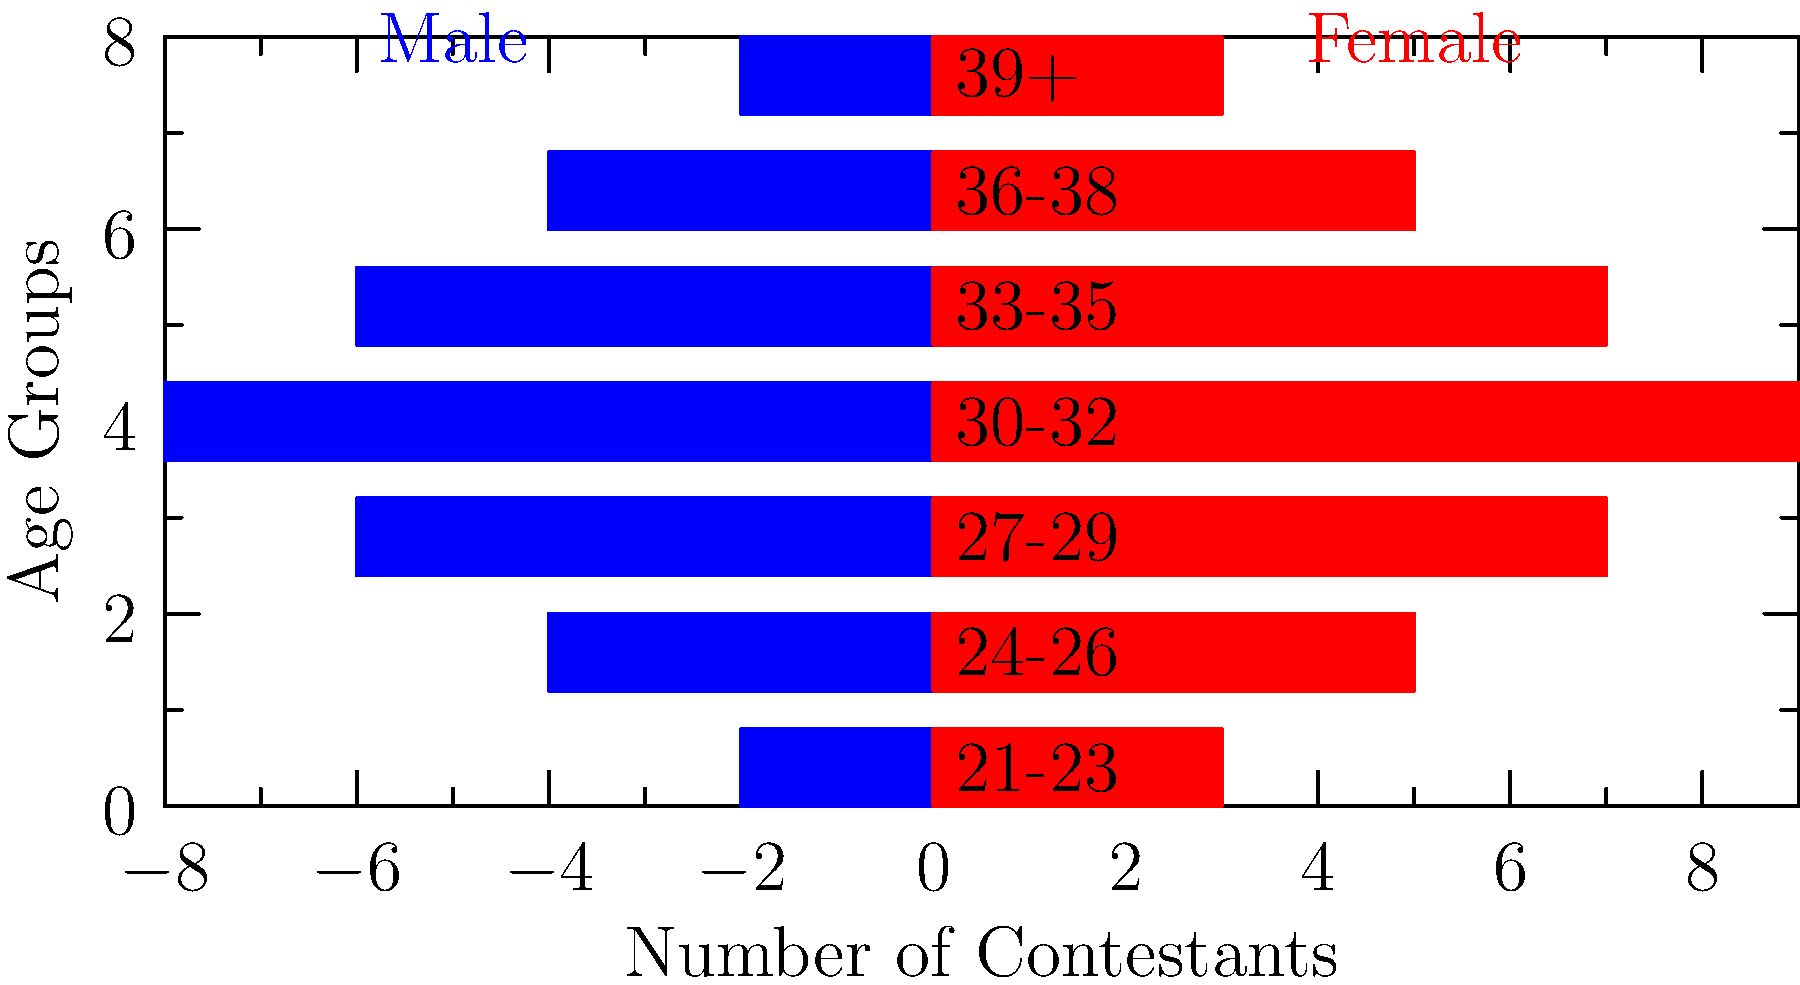Based on the population pyramid shown, which age group demonstrates the most significant gender disparity among contestants, and what might this imply about casting strategies for The Bachelor franchise? To answer this question, we need to analyze the population pyramid step-by-step:

1. Examine each age group:
   21-23: Male = 2, Female = 3
   24-26: Male = 4, Female = 5
   27-29: Male = 6, Female = 7
   30-32: Male = 8, Female = 9
   33-35: Male = 6, Female = 7
   36-38: Male = 4, Female = 5
   39+: Male = 2, Female = 3

2. Calculate the difference between male and female contestants for each age group:
   21-23: 3 - 2 = 1
   24-26: 5 - 4 = 1
   27-29: 7 - 6 = 1
   30-32: 9 - 8 = 1
   33-35: 7 - 6 = 1
   36-38: 5 - 4 = 1
   39+: 3 - 2 = 1

3. Observe that the absolute difference is consistent across all age groups (1 more female than male).

4. However, the most significant disparity in terms of proportion is in the 30-32 age group, which has the highest number of contestants for both genders.

5. This implies that the casting strategy focuses on having slightly more women than men across all age groups, but particularly emphasizes contestants in their early 30s.

6. The emphasis on the 30-32 age group might suggest that the show aims to appeal to viewers in this demographic or believes that contestants of this age are more likely to be ready for marriage.

7. The consistent gender disparity across all age groups indicates a deliberate casting strategy to have more female contestants, possibly to create more competition or drama in "The Bachelor" seasons compared to "The Bachelorette" seasons.
Answer: 30-32 age group; implies focus on early 30s contestants with slightly more women across all ages. 